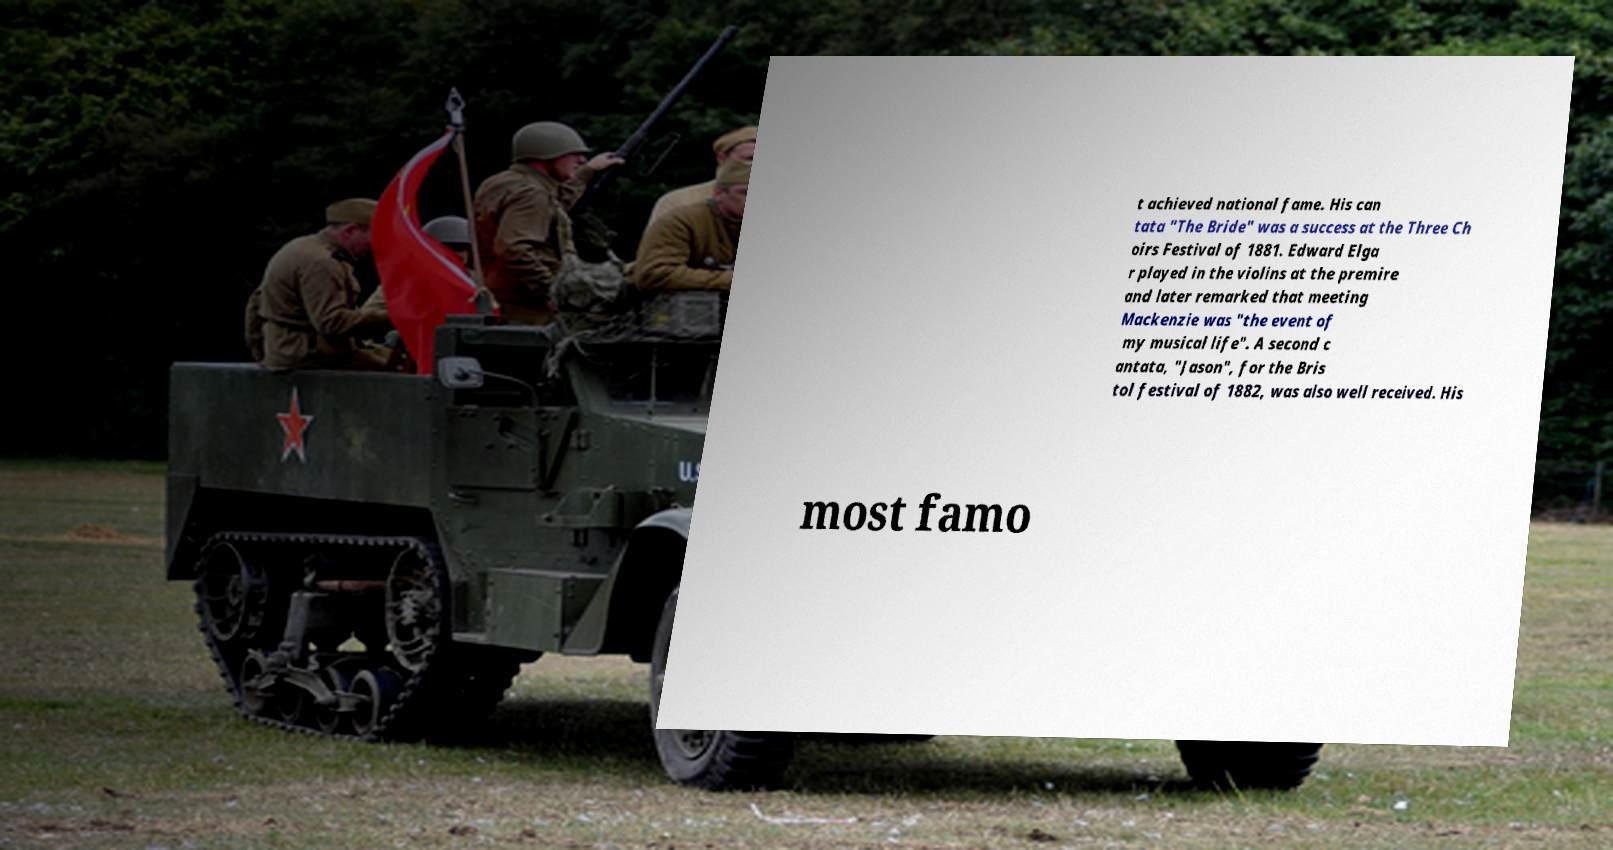There's text embedded in this image that I need extracted. Can you transcribe it verbatim? t achieved national fame. His can tata "The Bride" was a success at the Three Ch oirs Festival of 1881. Edward Elga r played in the violins at the premire and later remarked that meeting Mackenzie was "the event of my musical life". A second c antata, "Jason", for the Bris tol festival of 1882, was also well received. His most famo 